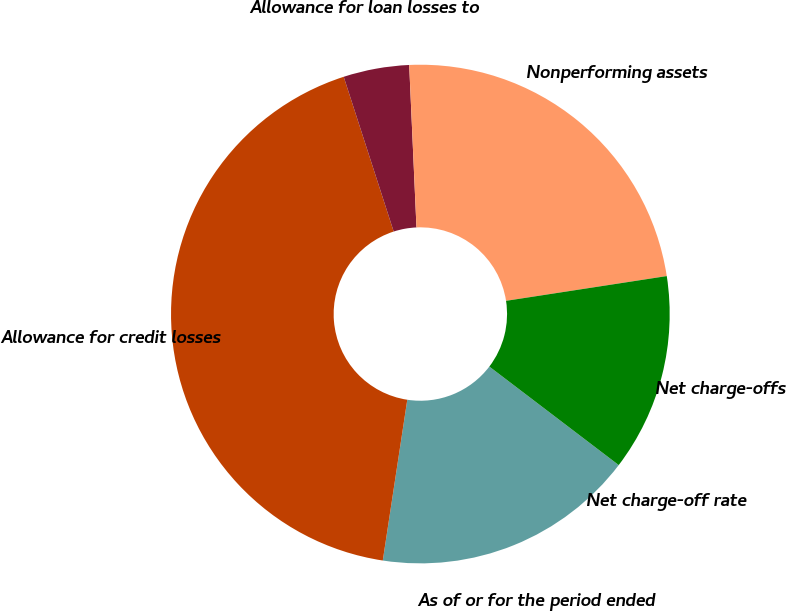Convert chart. <chart><loc_0><loc_0><loc_500><loc_500><pie_chart><fcel>As of or for the period ended<fcel>Allowance for credit losses<fcel>Allowance for loan losses to<fcel>Nonperforming assets<fcel>Net charge-offs<fcel>Net charge-off rate<nl><fcel>17.05%<fcel>42.62%<fcel>4.26%<fcel>23.28%<fcel>12.79%<fcel>0.0%<nl></chart> 